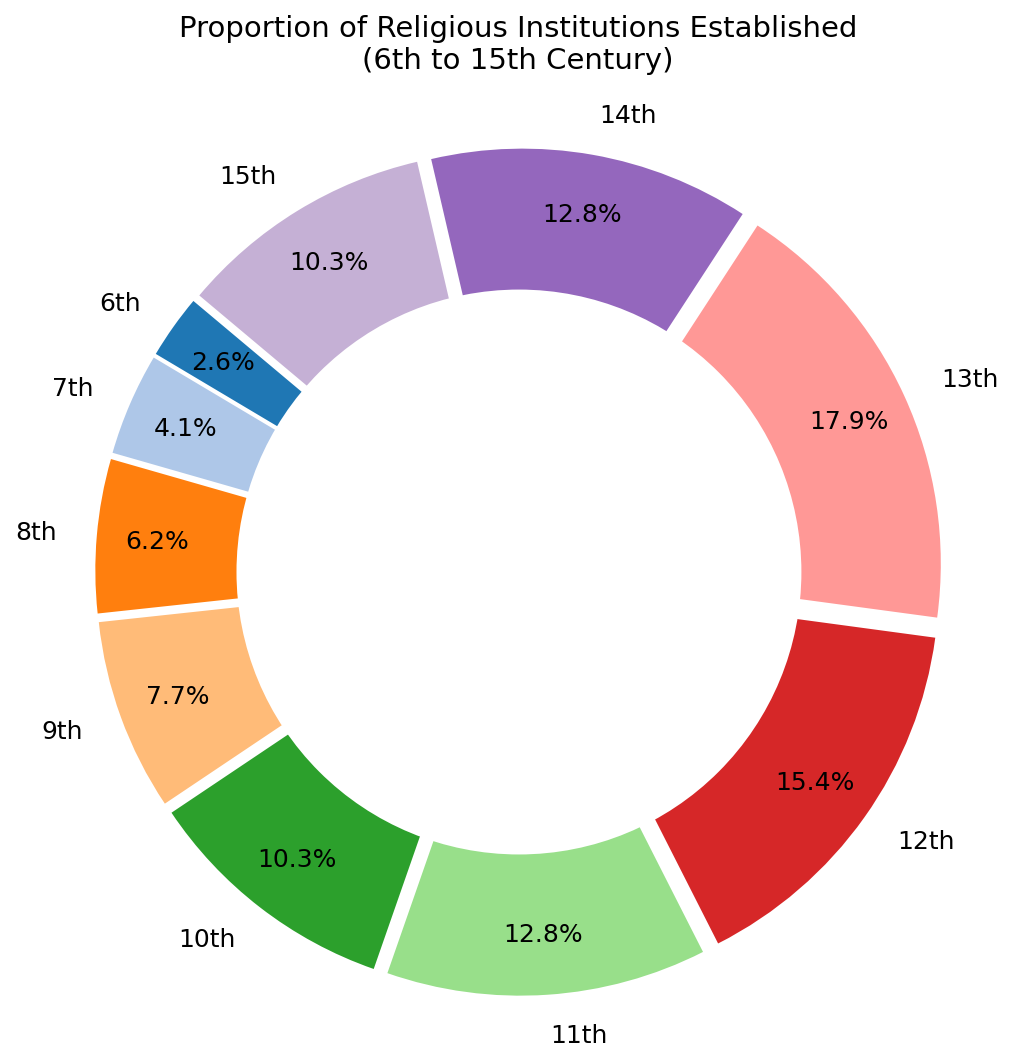Which century has the highest proportion of religious institutions established? Look for the largest slice in the pie chart, which represents the century with the highest proportion. The 13th century has the largest proportion of 35%
Answer: 13th century Which century has the smallest proportion of religious institutions established? Look for the smallest slice in the pie chart, which represents the century with the smallest proportion. The 6th century has the smallest proportion of 5%
Answer: 6th century What is the total proportion of religious institutions established from the 11th to the 13th centuries? Sum the slices corresponding to the 11th (25%), 12th (30%), and 13th (35%) centuries. The total proportion is 25% + 30% + 35% = 90%
Answer: 90% Are there any centuries with equal proportions of religious institutions established? Compare the proportions of each century to find if any are equal. The 10th and 15th centuries both have 20%
Answer: 10th and 15th centuries Which century has a higher proportion of religious institutions established, the 9th or the 7th? Compare the slices for the 9th century (15%) and the 7th century (8%). The 9th century has a higher proportion than the 7th century.
Answer: 9th century How much greater is the proportion of religious institutions established in the 13th century compared to the 6th century? Subtract the 6th century proportion (5%) from the 13th century proportion (35%). The difference is 35% - 5% = 30%
Answer: 30% Which century’s slice has a radius starting closer to the 3 o'clock position in the pie chart, the 12th or the 7th? The pie chart is likely starting at the 3 o'clock position, and the 12th century slice appears more to the right compared to the 7th century slice, beginning closer to the 3 o'clock position.
Answer: 12th century What is the average proportion of religious institutions established in the 6th, 7th, and 8th centuries? Sum the proportions of the 6th (5%), 7th (8%), and 8th (12%) centuries and divide by 3. (5% + 8% + 12%) / 3 = 25% / 3 = 8.33%
Answer: 8.33% If you combine the proportions of the 9th and 10th centuries, does it exceed the proportion of the 13th century? Sum the proportions of the 9th (15%) and 10th (20%) centuries and compare with the 13th century (35%). 15% + 20% = 35%, which equals the 13th century proportion
Answer: No Can you identify which century has a notable growth of religious institution establishments compared to the previous century by the visual prominence of the slice? The 13th century slice is notably larger than the 12th century slice, indicating significant growth.
Answer: 13th century 